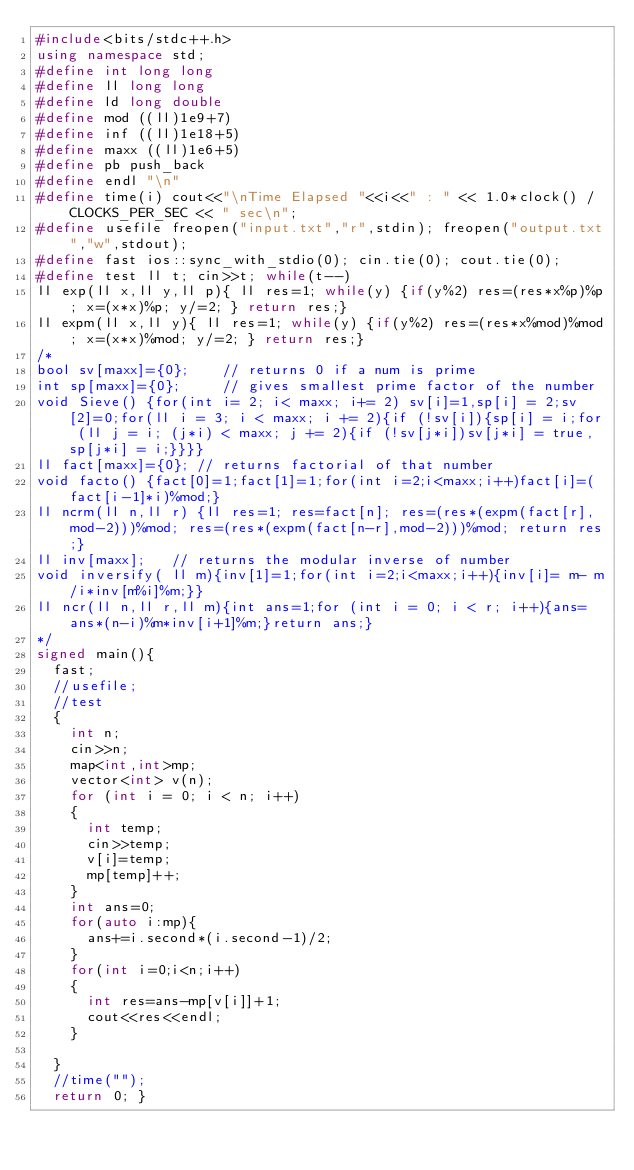Convert code to text. <code><loc_0><loc_0><loc_500><loc_500><_C++_>#include<bits/stdc++.h>
using namespace std;
#define int long long
#define ll long long
#define ld long double
#define mod ((ll)1e9+7)
#define inf ((ll)1e18+5)
#define maxx ((ll)1e6+5)
#define pb push_back
#define endl "\n"
#define time(i) cout<<"\nTime Elapsed "<<i<<" : " << 1.0*clock() / CLOCKS_PER_SEC << " sec\n";
#define usefile freopen("input.txt","r",stdin); freopen("output.txt","w",stdout);
#define fast ios::sync_with_stdio(0); cin.tie(0); cout.tie(0);
#define test ll t; cin>>t; while(t--)
ll exp(ll x,ll y,ll p){ ll res=1; while(y) {if(y%2) res=(res*x%p)%p; x=(x*x)%p; y/=2; } return res;}
ll expm(ll x,ll y){ ll res=1; while(y) {if(y%2) res=(res*x%mod)%mod; x=(x*x)%mod; y/=2; } return res;}
/*
bool sv[maxx]={0};    // returns 0 if a num is prime
int sp[maxx]={0};     // gives smallest prime factor of the number
void Sieve() {for(int i= 2; i< maxx; i+= 2) sv[i]=1,sp[i] = 2;sv[2]=0;for(ll i = 3; i < maxx; i += 2){if (!sv[i]){sp[i] = i;for (ll j = i; (j*i) < maxx; j += 2){if (!sv[j*i])sv[j*i] = true, sp[j*i] = i;}}}}
ll fact[maxx]={0}; // returns factorial of that number
void facto() {fact[0]=1;fact[1]=1;for(int i=2;i<maxx;i++)fact[i]=(fact[i-1]*i)%mod;}
ll ncrm(ll n,ll r) {ll res=1; res=fact[n]; res=(res*(expm(fact[r],mod-2)))%mod; res=(res*(expm(fact[n-r],mod-2)))%mod; return res;}
ll inv[maxx];   // returns the modular inverse of number
void inversify( ll m){inv[1]=1;for(int i=2;i<maxx;i++){inv[i]= m- m/i*inv[m%i]%m;}}
ll ncr(ll n,ll r,ll m){int ans=1;for (int i = 0; i < r; i++){ans=ans*(n-i)%m*inv[i+1]%m;}return ans;}
*/
signed main(){
  fast;
  //usefile;
  //test
  {
    int n;
    cin>>n;
    map<int,int>mp;
    vector<int> v(n);
    for (int i = 0; i < n; i++)
    {
      int temp;
      cin>>temp;
      v[i]=temp;
      mp[temp]++;
    }
    int ans=0;
    for(auto i:mp){
      ans+=i.second*(i.second-1)/2;
    }
    for(int i=0;i<n;i++)
    {
      int res=ans-mp[v[i]]+1;
      cout<<res<<endl;
    }
    
  }
  //time("");
  return 0; }
</code> 